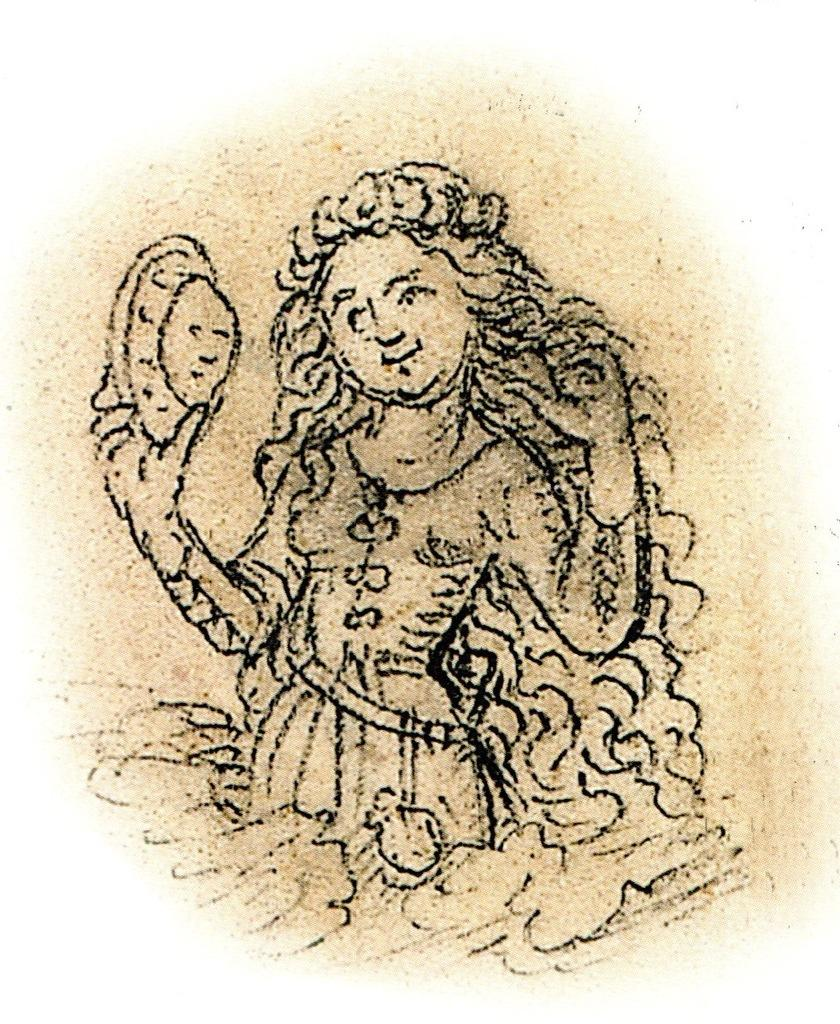What is the main subject of the image? There is a picture of a girl in the image. What is the girl doing in the image? The girl is holding an object. What color is the sky in the image? There is no sky visible in the image, as it is a picture of a girl holding an object. What is the girl resting on in the image? The girl is not resting on anything in the image; she is standing and holding an object. 